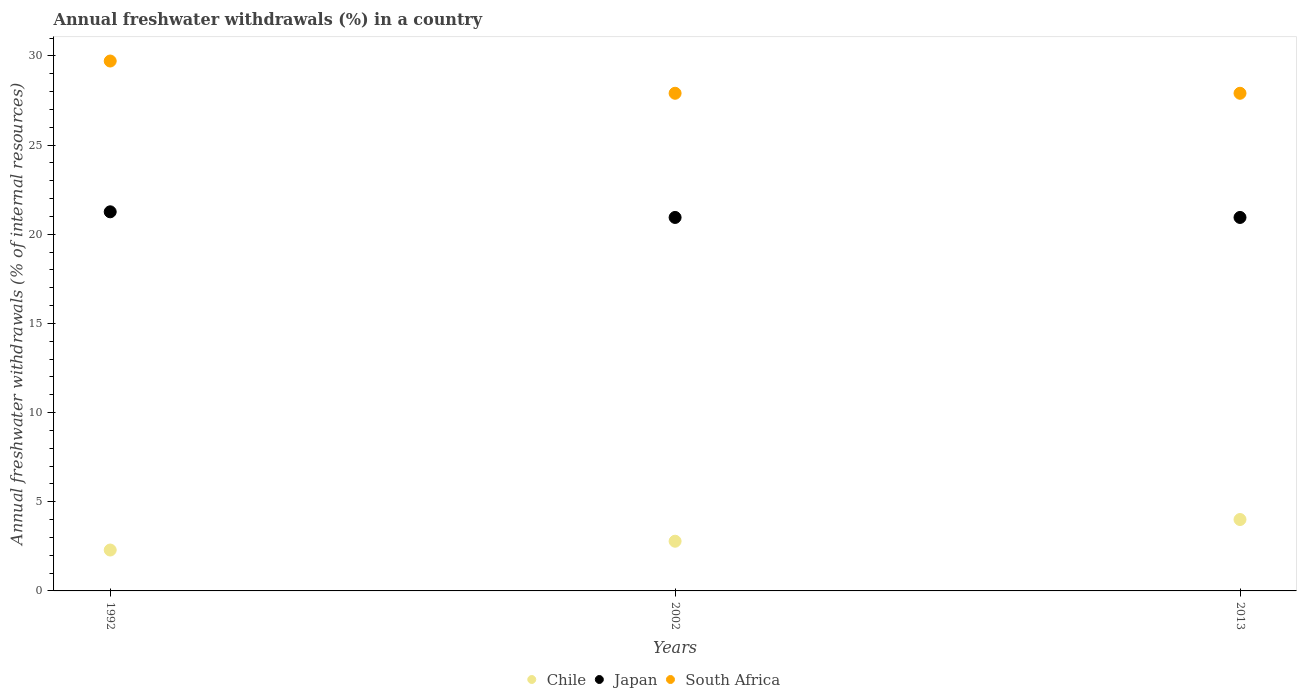How many different coloured dotlines are there?
Provide a short and direct response. 3. Is the number of dotlines equal to the number of legend labels?
Give a very brief answer. Yes. What is the percentage of annual freshwater withdrawals in Chile in 1992?
Provide a short and direct response. 2.29. Across all years, what is the maximum percentage of annual freshwater withdrawals in Japan?
Your response must be concise. 21.26. Across all years, what is the minimum percentage of annual freshwater withdrawals in Japan?
Give a very brief answer. 20.94. In which year was the percentage of annual freshwater withdrawals in Japan maximum?
Make the answer very short. 1992. What is the total percentage of annual freshwater withdrawals in Chile in the graph?
Provide a short and direct response. 9.08. What is the difference between the percentage of annual freshwater withdrawals in South Africa in 1992 and that in 2013?
Offer a very short reply. 1.81. What is the difference between the percentage of annual freshwater withdrawals in South Africa in 2002 and the percentage of annual freshwater withdrawals in Chile in 1992?
Give a very brief answer. 25.61. What is the average percentage of annual freshwater withdrawals in South Africa per year?
Your answer should be very brief. 28.5. In the year 2013, what is the difference between the percentage of annual freshwater withdrawals in Japan and percentage of annual freshwater withdrawals in South Africa?
Provide a succinct answer. -6.96. What is the ratio of the percentage of annual freshwater withdrawals in South Africa in 1992 to that in 2013?
Give a very brief answer. 1.06. Is the difference between the percentage of annual freshwater withdrawals in Japan in 1992 and 2013 greater than the difference between the percentage of annual freshwater withdrawals in South Africa in 1992 and 2013?
Ensure brevity in your answer.  No. What is the difference between the highest and the second highest percentage of annual freshwater withdrawals in South Africa?
Offer a very short reply. 1.81. What is the difference between the highest and the lowest percentage of annual freshwater withdrawals in Chile?
Offer a very short reply. 1.71. In how many years, is the percentage of annual freshwater withdrawals in Japan greater than the average percentage of annual freshwater withdrawals in Japan taken over all years?
Offer a terse response. 1. Is the sum of the percentage of annual freshwater withdrawals in Japan in 1992 and 2002 greater than the maximum percentage of annual freshwater withdrawals in Chile across all years?
Ensure brevity in your answer.  Yes. Is it the case that in every year, the sum of the percentage of annual freshwater withdrawals in Chile and percentage of annual freshwater withdrawals in South Africa  is greater than the percentage of annual freshwater withdrawals in Japan?
Offer a very short reply. Yes. Does the percentage of annual freshwater withdrawals in Chile monotonically increase over the years?
Make the answer very short. Yes. Is the percentage of annual freshwater withdrawals in Japan strictly greater than the percentage of annual freshwater withdrawals in Chile over the years?
Keep it short and to the point. Yes. How many dotlines are there?
Provide a succinct answer. 3. Does the graph contain grids?
Your answer should be very brief. No. How are the legend labels stacked?
Ensure brevity in your answer.  Horizontal. What is the title of the graph?
Make the answer very short. Annual freshwater withdrawals (%) in a country. Does "Peru" appear as one of the legend labels in the graph?
Make the answer very short. No. What is the label or title of the X-axis?
Offer a terse response. Years. What is the label or title of the Y-axis?
Your answer should be compact. Annual freshwater withdrawals (% of internal resources). What is the Annual freshwater withdrawals (% of internal resources) of Chile in 1992?
Ensure brevity in your answer.  2.29. What is the Annual freshwater withdrawals (% of internal resources) of Japan in 1992?
Your response must be concise. 21.26. What is the Annual freshwater withdrawals (% of internal resources) of South Africa in 1992?
Your response must be concise. 29.71. What is the Annual freshwater withdrawals (% of internal resources) of Chile in 2002?
Your answer should be very brief. 2.79. What is the Annual freshwater withdrawals (% of internal resources) in Japan in 2002?
Offer a very short reply. 20.94. What is the Annual freshwater withdrawals (% of internal resources) in South Africa in 2002?
Provide a short and direct response. 27.9. What is the Annual freshwater withdrawals (% of internal resources) of Chile in 2013?
Your response must be concise. 4. What is the Annual freshwater withdrawals (% of internal resources) of Japan in 2013?
Your answer should be compact. 20.94. What is the Annual freshwater withdrawals (% of internal resources) of South Africa in 2013?
Offer a terse response. 27.9. Across all years, what is the maximum Annual freshwater withdrawals (% of internal resources) of Chile?
Your answer should be very brief. 4. Across all years, what is the maximum Annual freshwater withdrawals (% of internal resources) of Japan?
Offer a terse response. 21.26. Across all years, what is the maximum Annual freshwater withdrawals (% of internal resources) of South Africa?
Offer a very short reply. 29.71. Across all years, what is the minimum Annual freshwater withdrawals (% of internal resources) in Chile?
Make the answer very short. 2.29. Across all years, what is the minimum Annual freshwater withdrawals (% of internal resources) of Japan?
Your answer should be very brief. 20.94. Across all years, what is the minimum Annual freshwater withdrawals (% of internal resources) of South Africa?
Keep it short and to the point. 27.9. What is the total Annual freshwater withdrawals (% of internal resources) in Chile in the graph?
Offer a very short reply. 9.08. What is the total Annual freshwater withdrawals (% of internal resources) of Japan in the graph?
Offer a terse response. 63.13. What is the total Annual freshwater withdrawals (% of internal resources) of South Africa in the graph?
Offer a very short reply. 85.51. What is the difference between the Annual freshwater withdrawals (% of internal resources) in Chile in 1992 and that in 2002?
Provide a succinct answer. -0.49. What is the difference between the Annual freshwater withdrawals (% of internal resources) in Japan in 1992 and that in 2002?
Your response must be concise. 0.32. What is the difference between the Annual freshwater withdrawals (% of internal resources) of South Africa in 1992 and that in 2002?
Keep it short and to the point. 1.81. What is the difference between the Annual freshwater withdrawals (% of internal resources) of Chile in 1992 and that in 2013?
Offer a very short reply. -1.71. What is the difference between the Annual freshwater withdrawals (% of internal resources) of Japan in 1992 and that in 2013?
Your response must be concise. 0.32. What is the difference between the Annual freshwater withdrawals (% of internal resources) in South Africa in 1992 and that in 2013?
Provide a succinct answer. 1.81. What is the difference between the Annual freshwater withdrawals (% of internal resources) in Chile in 2002 and that in 2013?
Your response must be concise. -1.22. What is the difference between the Annual freshwater withdrawals (% of internal resources) of South Africa in 2002 and that in 2013?
Offer a terse response. 0. What is the difference between the Annual freshwater withdrawals (% of internal resources) in Chile in 1992 and the Annual freshwater withdrawals (% of internal resources) in Japan in 2002?
Your answer should be compact. -18.65. What is the difference between the Annual freshwater withdrawals (% of internal resources) of Chile in 1992 and the Annual freshwater withdrawals (% of internal resources) of South Africa in 2002?
Your response must be concise. -25.61. What is the difference between the Annual freshwater withdrawals (% of internal resources) of Japan in 1992 and the Annual freshwater withdrawals (% of internal resources) of South Africa in 2002?
Provide a short and direct response. -6.65. What is the difference between the Annual freshwater withdrawals (% of internal resources) of Chile in 1992 and the Annual freshwater withdrawals (% of internal resources) of Japan in 2013?
Ensure brevity in your answer.  -18.65. What is the difference between the Annual freshwater withdrawals (% of internal resources) of Chile in 1992 and the Annual freshwater withdrawals (% of internal resources) of South Africa in 2013?
Offer a very short reply. -25.61. What is the difference between the Annual freshwater withdrawals (% of internal resources) of Japan in 1992 and the Annual freshwater withdrawals (% of internal resources) of South Africa in 2013?
Your answer should be very brief. -6.65. What is the difference between the Annual freshwater withdrawals (% of internal resources) of Chile in 2002 and the Annual freshwater withdrawals (% of internal resources) of Japan in 2013?
Provide a short and direct response. -18.15. What is the difference between the Annual freshwater withdrawals (% of internal resources) of Chile in 2002 and the Annual freshwater withdrawals (% of internal resources) of South Africa in 2013?
Your answer should be compact. -25.12. What is the difference between the Annual freshwater withdrawals (% of internal resources) of Japan in 2002 and the Annual freshwater withdrawals (% of internal resources) of South Africa in 2013?
Provide a short and direct response. -6.96. What is the average Annual freshwater withdrawals (% of internal resources) of Chile per year?
Keep it short and to the point. 3.03. What is the average Annual freshwater withdrawals (% of internal resources) of Japan per year?
Provide a short and direct response. 21.05. What is the average Annual freshwater withdrawals (% of internal resources) in South Africa per year?
Offer a very short reply. 28.5. In the year 1992, what is the difference between the Annual freshwater withdrawals (% of internal resources) of Chile and Annual freshwater withdrawals (% of internal resources) of Japan?
Provide a short and direct response. -18.96. In the year 1992, what is the difference between the Annual freshwater withdrawals (% of internal resources) of Chile and Annual freshwater withdrawals (% of internal resources) of South Africa?
Your answer should be compact. -27.42. In the year 1992, what is the difference between the Annual freshwater withdrawals (% of internal resources) of Japan and Annual freshwater withdrawals (% of internal resources) of South Africa?
Ensure brevity in your answer.  -8.45. In the year 2002, what is the difference between the Annual freshwater withdrawals (% of internal resources) of Chile and Annual freshwater withdrawals (% of internal resources) of Japan?
Provide a short and direct response. -18.15. In the year 2002, what is the difference between the Annual freshwater withdrawals (% of internal resources) of Chile and Annual freshwater withdrawals (% of internal resources) of South Africa?
Keep it short and to the point. -25.12. In the year 2002, what is the difference between the Annual freshwater withdrawals (% of internal resources) in Japan and Annual freshwater withdrawals (% of internal resources) in South Africa?
Ensure brevity in your answer.  -6.96. In the year 2013, what is the difference between the Annual freshwater withdrawals (% of internal resources) of Chile and Annual freshwater withdrawals (% of internal resources) of Japan?
Provide a short and direct response. -16.94. In the year 2013, what is the difference between the Annual freshwater withdrawals (% of internal resources) of Chile and Annual freshwater withdrawals (% of internal resources) of South Africa?
Provide a short and direct response. -23.9. In the year 2013, what is the difference between the Annual freshwater withdrawals (% of internal resources) of Japan and Annual freshwater withdrawals (% of internal resources) of South Africa?
Ensure brevity in your answer.  -6.96. What is the ratio of the Annual freshwater withdrawals (% of internal resources) of Chile in 1992 to that in 2002?
Your response must be concise. 0.82. What is the ratio of the Annual freshwater withdrawals (% of internal resources) of Japan in 1992 to that in 2002?
Keep it short and to the point. 1.02. What is the ratio of the Annual freshwater withdrawals (% of internal resources) in South Africa in 1992 to that in 2002?
Provide a short and direct response. 1.06. What is the ratio of the Annual freshwater withdrawals (% of internal resources) of Chile in 1992 to that in 2013?
Ensure brevity in your answer.  0.57. What is the ratio of the Annual freshwater withdrawals (% of internal resources) in Japan in 1992 to that in 2013?
Ensure brevity in your answer.  1.02. What is the ratio of the Annual freshwater withdrawals (% of internal resources) in South Africa in 1992 to that in 2013?
Keep it short and to the point. 1.06. What is the ratio of the Annual freshwater withdrawals (% of internal resources) of Chile in 2002 to that in 2013?
Your answer should be very brief. 0.7. What is the ratio of the Annual freshwater withdrawals (% of internal resources) of Japan in 2002 to that in 2013?
Your response must be concise. 1. What is the difference between the highest and the second highest Annual freshwater withdrawals (% of internal resources) of Chile?
Offer a very short reply. 1.22. What is the difference between the highest and the second highest Annual freshwater withdrawals (% of internal resources) in Japan?
Your answer should be very brief. 0.32. What is the difference between the highest and the second highest Annual freshwater withdrawals (% of internal resources) of South Africa?
Ensure brevity in your answer.  1.81. What is the difference between the highest and the lowest Annual freshwater withdrawals (% of internal resources) of Chile?
Keep it short and to the point. 1.71. What is the difference between the highest and the lowest Annual freshwater withdrawals (% of internal resources) in Japan?
Make the answer very short. 0.32. What is the difference between the highest and the lowest Annual freshwater withdrawals (% of internal resources) in South Africa?
Your answer should be compact. 1.81. 